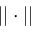Convert formula to latex. <formula><loc_0><loc_0><loc_500><loc_500>| | \cdot | |</formula> 